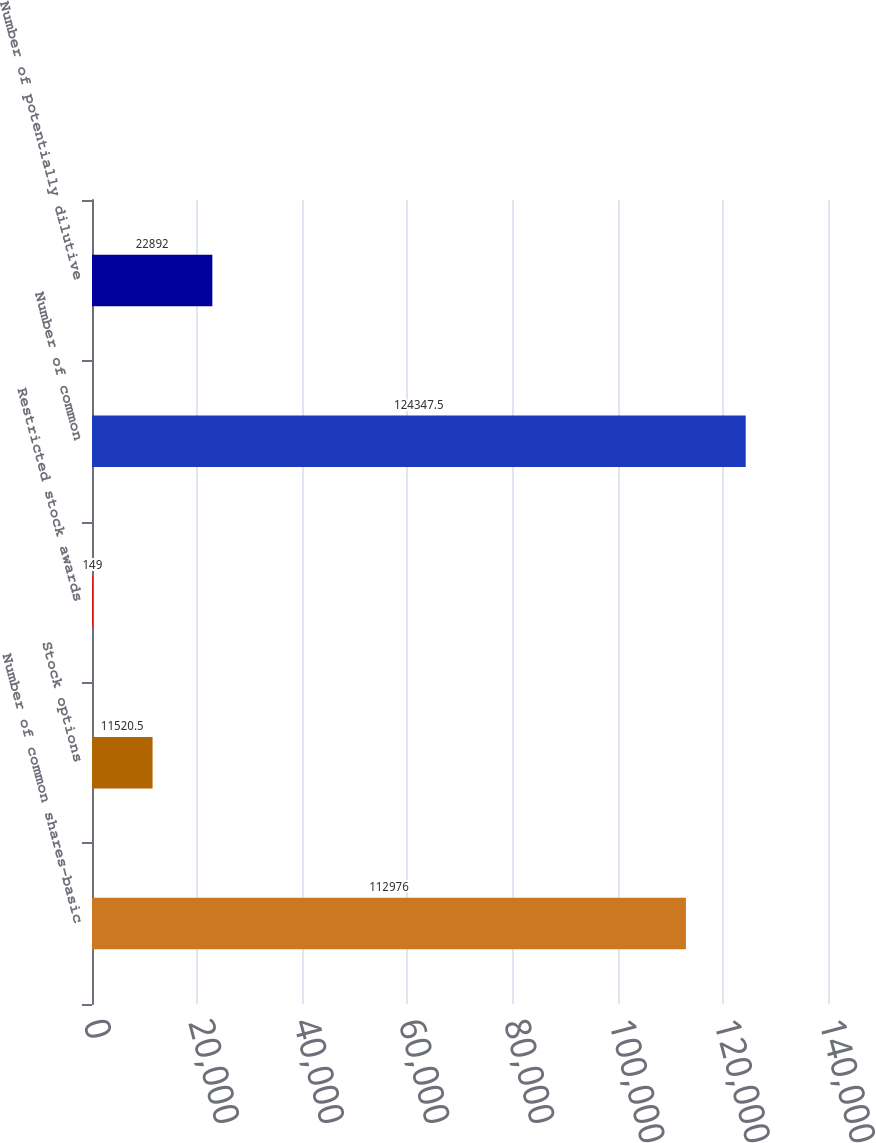Convert chart. <chart><loc_0><loc_0><loc_500><loc_500><bar_chart><fcel>Number of common shares-basic<fcel>Stock options<fcel>Restricted stock awards<fcel>Number of common<fcel>Number of potentially dilutive<nl><fcel>112976<fcel>11520.5<fcel>149<fcel>124348<fcel>22892<nl></chart> 